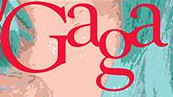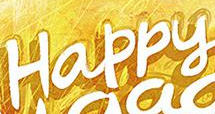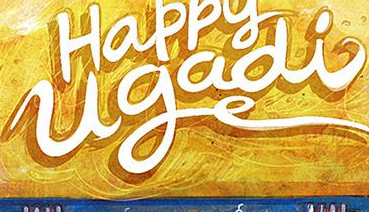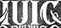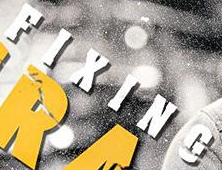Read the text content from these images in order, separated by a semicolon. Gaga; Happy; ugadi; IUIC; FIXING 